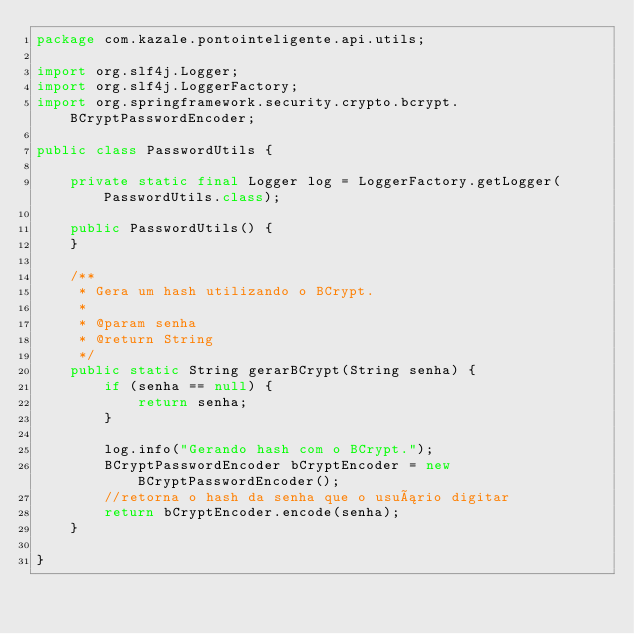<code> <loc_0><loc_0><loc_500><loc_500><_Java_>package com.kazale.pontointeligente.api.utils;

import org.slf4j.Logger;
import org.slf4j.LoggerFactory;
import org.springframework.security.crypto.bcrypt.BCryptPasswordEncoder;

public class PasswordUtils {

	private static final Logger log = LoggerFactory.getLogger(PasswordUtils.class);

	public PasswordUtils() {
	}

	/**
	 * Gera um hash utilizando o BCrypt.
	 * 
	 * @param senha
	 * @return String
	 */
	public static String gerarBCrypt(String senha) {
		if (senha == null) {
			return senha;
		}

		log.info("Gerando hash com o BCrypt.");
		BCryptPasswordEncoder bCryptEncoder = new BCryptPasswordEncoder();
		//retorna o hash da senha que o usuário digitar
		return bCryptEncoder.encode(senha);
	}

}
</code> 